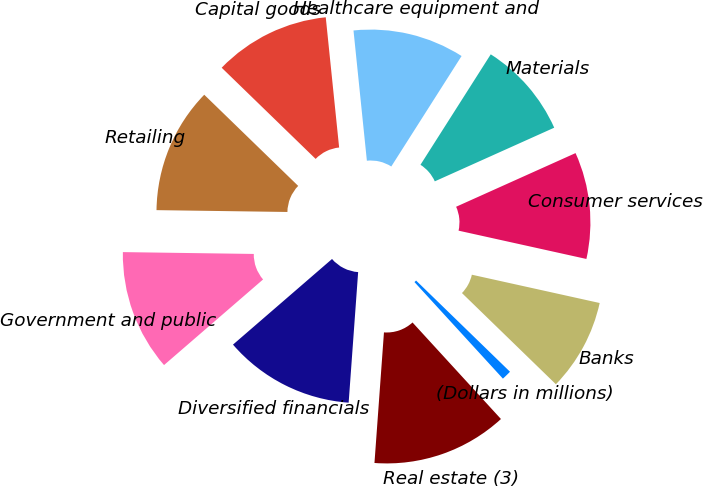<chart> <loc_0><loc_0><loc_500><loc_500><pie_chart><fcel>(Dollars in millions)<fcel>Real estate (3)<fcel>Diversified financials<fcel>Government and public<fcel>Retailing<fcel>Capital goods<fcel>Healthcare equipment and<fcel>Materials<fcel>Consumer services<fcel>Banks<nl><fcel>0.93%<fcel>12.96%<fcel>12.5%<fcel>11.57%<fcel>12.04%<fcel>11.11%<fcel>10.65%<fcel>9.26%<fcel>10.19%<fcel>8.8%<nl></chart> 